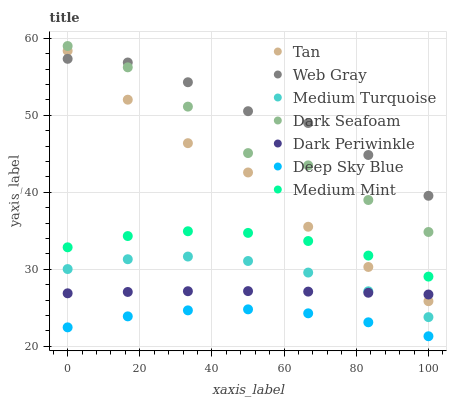Does Deep Sky Blue have the minimum area under the curve?
Answer yes or no. Yes. Does Web Gray have the maximum area under the curve?
Answer yes or no. Yes. Does Medium Turquoise have the minimum area under the curve?
Answer yes or no. No. Does Medium Turquoise have the maximum area under the curve?
Answer yes or no. No. Is Dark Periwinkle the smoothest?
Answer yes or no. Yes. Is Dark Seafoam the roughest?
Answer yes or no. Yes. Is Web Gray the smoothest?
Answer yes or no. No. Is Web Gray the roughest?
Answer yes or no. No. Does Deep Sky Blue have the lowest value?
Answer yes or no. Yes. Does Medium Turquoise have the lowest value?
Answer yes or no. No. Does Dark Seafoam have the highest value?
Answer yes or no. Yes. Does Web Gray have the highest value?
Answer yes or no. No. Is Medium Turquoise less than Web Gray?
Answer yes or no. Yes. Is Tan greater than Medium Turquoise?
Answer yes or no. Yes. Does Web Gray intersect Tan?
Answer yes or no. Yes. Is Web Gray less than Tan?
Answer yes or no. No. Is Web Gray greater than Tan?
Answer yes or no. No. Does Medium Turquoise intersect Web Gray?
Answer yes or no. No. 